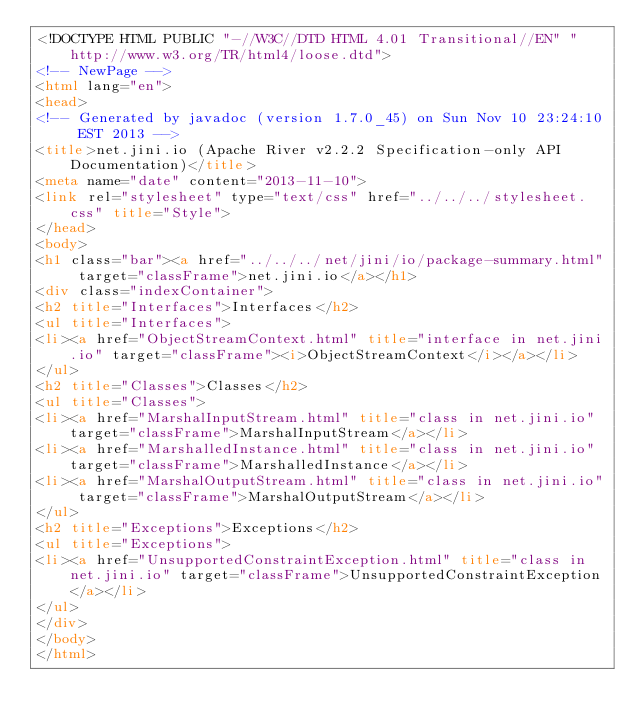Convert code to text. <code><loc_0><loc_0><loc_500><loc_500><_HTML_><!DOCTYPE HTML PUBLIC "-//W3C//DTD HTML 4.01 Transitional//EN" "http://www.w3.org/TR/html4/loose.dtd">
<!-- NewPage -->
<html lang="en">
<head>
<!-- Generated by javadoc (version 1.7.0_45) on Sun Nov 10 23:24:10 EST 2013 -->
<title>net.jini.io (Apache River v2.2.2 Specification-only API Documentation)</title>
<meta name="date" content="2013-11-10">
<link rel="stylesheet" type="text/css" href="../../../stylesheet.css" title="Style">
</head>
<body>
<h1 class="bar"><a href="../../../net/jini/io/package-summary.html" target="classFrame">net.jini.io</a></h1>
<div class="indexContainer">
<h2 title="Interfaces">Interfaces</h2>
<ul title="Interfaces">
<li><a href="ObjectStreamContext.html" title="interface in net.jini.io" target="classFrame"><i>ObjectStreamContext</i></a></li>
</ul>
<h2 title="Classes">Classes</h2>
<ul title="Classes">
<li><a href="MarshalInputStream.html" title="class in net.jini.io" target="classFrame">MarshalInputStream</a></li>
<li><a href="MarshalledInstance.html" title="class in net.jini.io" target="classFrame">MarshalledInstance</a></li>
<li><a href="MarshalOutputStream.html" title="class in net.jini.io" target="classFrame">MarshalOutputStream</a></li>
</ul>
<h2 title="Exceptions">Exceptions</h2>
<ul title="Exceptions">
<li><a href="UnsupportedConstraintException.html" title="class in net.jini.io" target="classFrame">UnsupportedConstraintException</a></li>
</ul>
</div>
</body>
</html>
</code> 